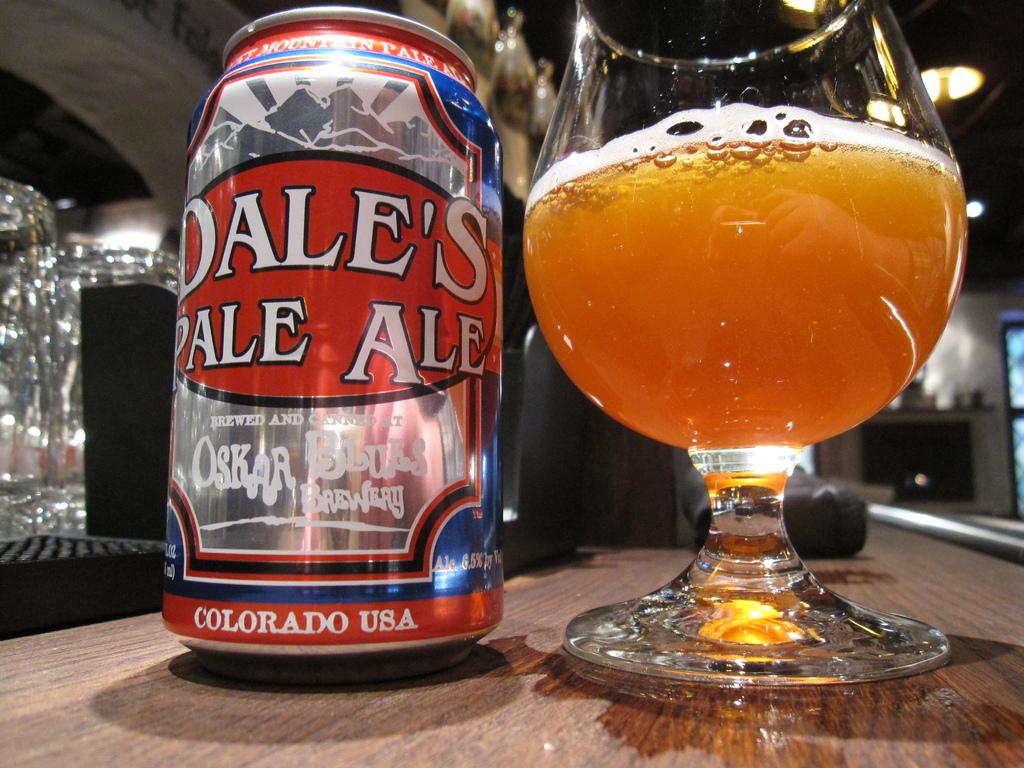What is inside of that can?
Your answer should be very brief. Dale's pale ale. 